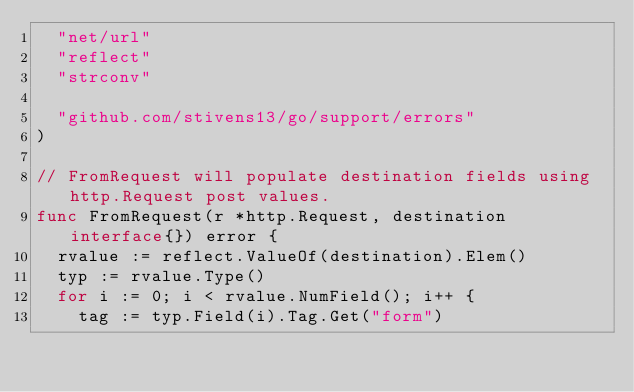<code> <loc_0><loc_0><loc_500><loc_500><_Go_>	"net/url"
	"reflect"
	"strconv"

	"github.com/stivens13/go/support/errors"
)

// FromRequest will populate destination fields using http.Request post values.
func FromRequest(r *http.Request, destination interface{}) error {
	rvalue := reflect.ValueOf(destination).Elem()
	typ := rvalue.Type()
	for i := 0; i < rvalue.NumField(); i++ {
		tag := typ.Field(i).Tag.Get("form")</code> 